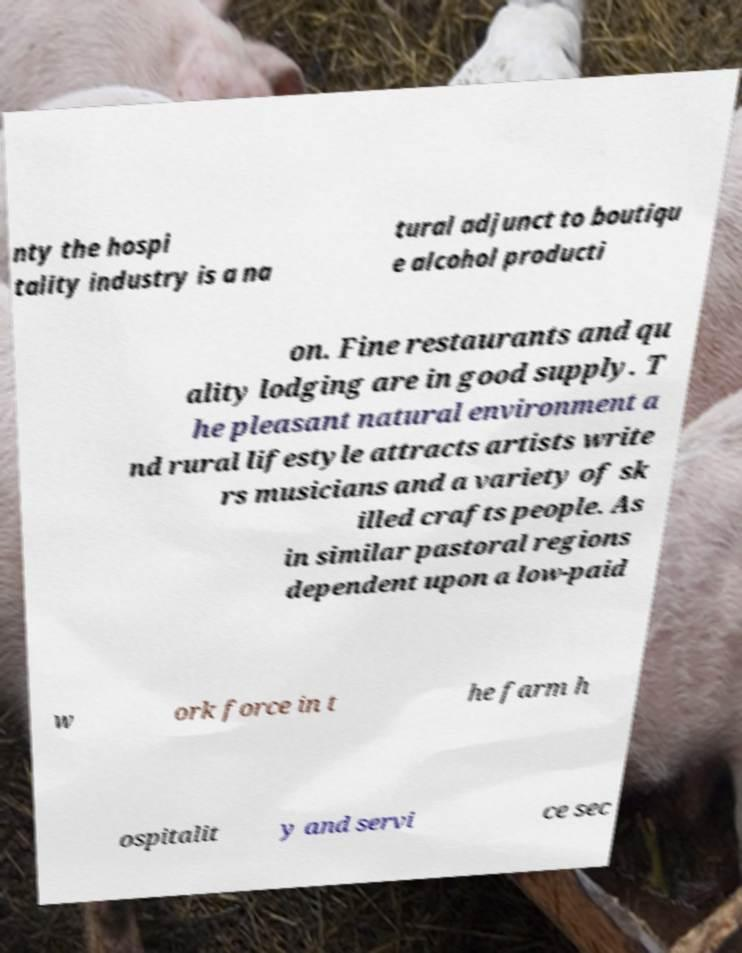Can you read and provide the text displayed in the image?This photo seems to have some interesting text. Can you extract and type it out for me? nty the hospi tality industry is a na tural adjunct to boutiqu e alcohol producti on. Fine restaurants and qu ality lodging are in good supply. T he pleasant natural environment a nd rural lifestyle attracts artists write rs musicians and a variety of sk illed crafts people. As in similar pastoral regions dependent upon a low-paid w ork force in t he farm h ospitalit y and servi ce sec 